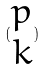<formula> <loc_0><loc_0><loc_500><loc_500>( \begin{matrix} p \\ k \end{matrix} )</formula> 